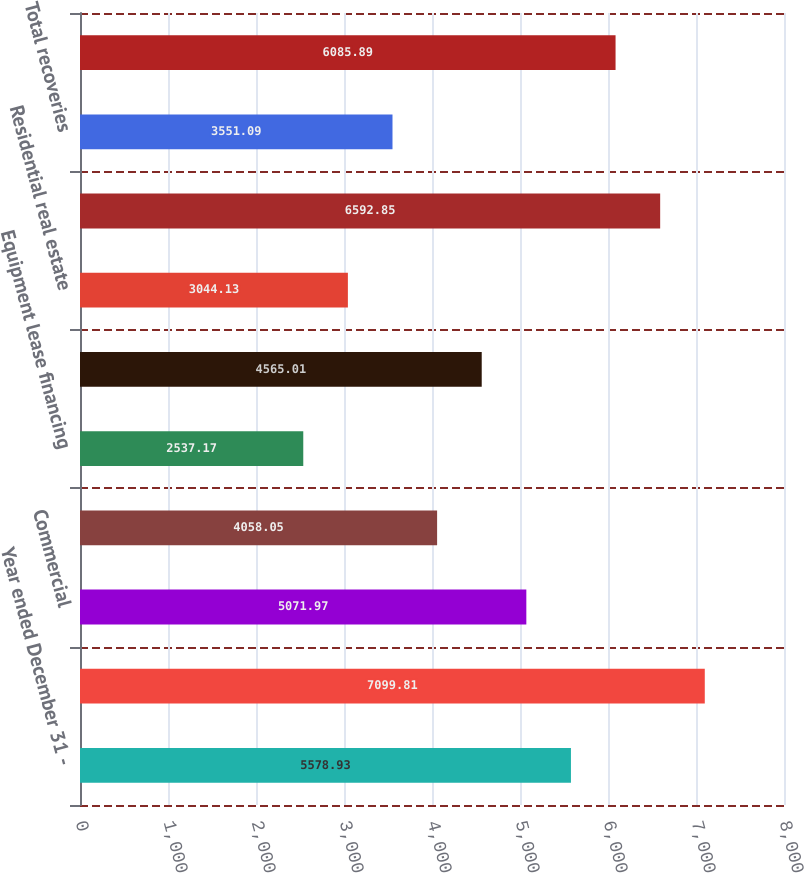<chart> <loc_0><loc_0><loc_500><loc_500><bar_chart><fcel>Year ended December 31 -<fcel>Allowance for loan and lease<fcel>Commercial<fcel>Commercial real estate<fcel>Equipment lease financing<fcel>Consumer (a)<fcel>Residential real estate<fcel>Total charge-offs<fcel>Total recoveries<fcel>Net charge-offs<nl><fcel>5578.93<fcel>7099.81<fcel>5071.97<fcel>4058.05<fcel>2537.17<fcel>4565.01<fcel>3044.13<fcel>6592.85<fcel>3551.09<fcel>6085.89<nl></chart> 